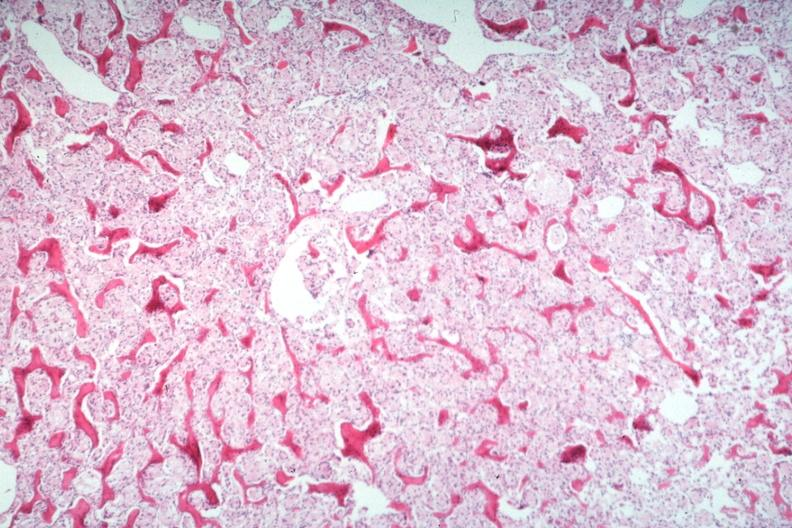what is present?
Answer the question using a single word or phrase. Joints 